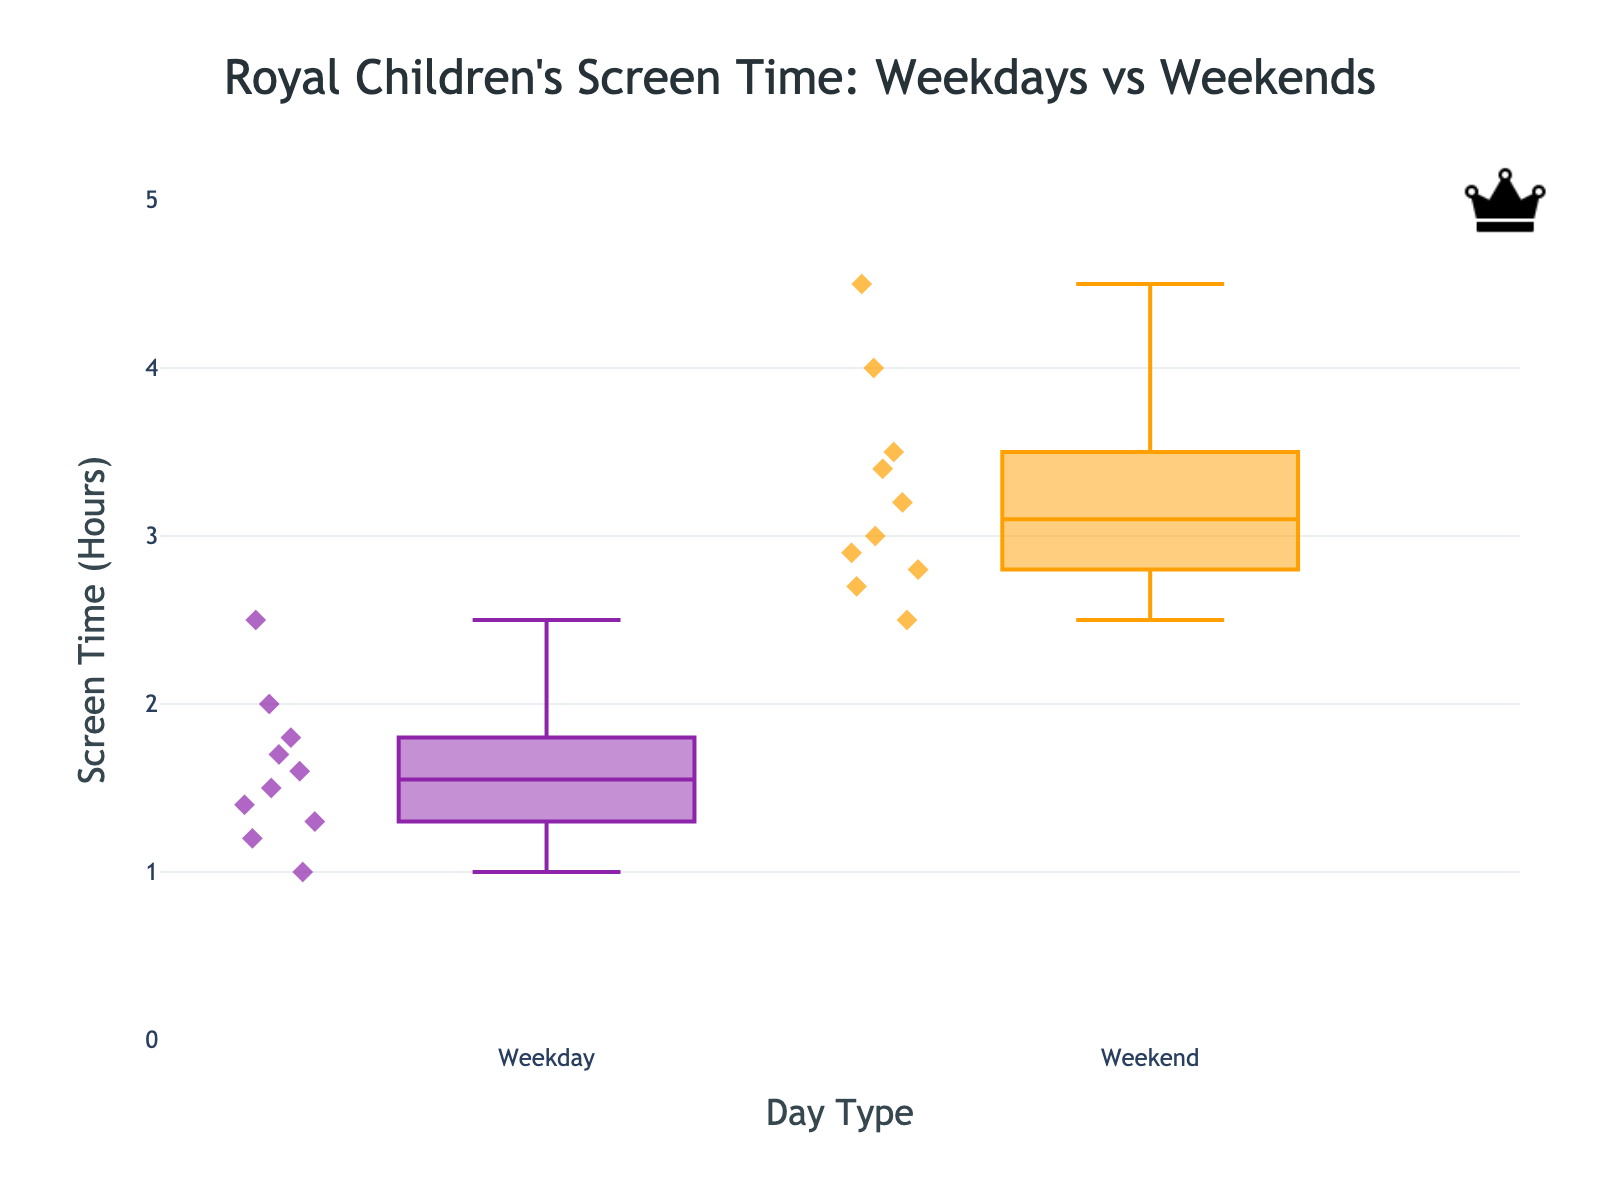What's the title of the figure? The title is usually located at the top of the figure and is clearly marked to describe what the plot depicts. In this case, it would describe the comparison of screen time for children over weekdays and weekends.
Answer: Royal Children's Screen Time: Weekdays vs Weekends What's the y-axis title? The y-axis title describes what the vertical axis represents, which is typically labeled directly on the axis itself.
Answer: Screen Time (Hours) How many hours is the median screen time for children on weekdays? The median is indicated by the line inside the box which represents the 50th percentile of the data. For the weekdays, locate this line within the box.
Answer: 1.5 hours Which day type has a higher median screen time? Compare the lines inside the boxes of both groups, as these lines represent the median values. The median for weekends should be higher than the median for weekdays.
Answer: Weekend What's the range of screen time recorded on both weekdays and weekends? The range can be found by subtracting the smallest value (bottom of the whisker) from the largest value (top of the whisker) for each group. Observe these values on both sides.
Answer: Weekdays: 1.0-2.5, Weekends: 2.5-4.5 By how much does the median screen time increase from weekdays to weekends? Determine the median screen time for both weekdays and weekends by locating the line inside the box for each group, then subtract the weekday median from the weekend median.
Answer: 1.5 hours Are there any outliers in the data? Outliers are represented by individual points that are distant from the rest of the data in the plot. Check if there are points that are isolated from the majority of other points.
Answer: No Which child has the highest screen time on weekends? Locate the highest point in the weekend box plot; this point will be labeled with the child's name.
Answer: Archie How does the interquartile range (IQR) for weekdays compare to that for weekends? The IQR is the range between the first quartile (bottom of the box) and the third quartile (top of the box). Observe the height of the boxes for each group to assess the IQRs.
Answer: Weekdays: ~0.4, Weekends: ~0.9 